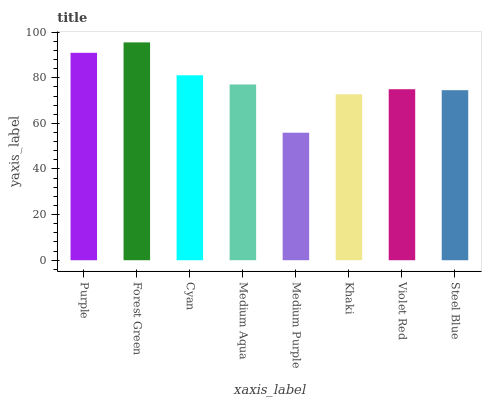Is Medium Purple the minimum?
Answer yes or no. Yes. Is Forest Green the maximum?
Answer yes or no. Yes. Is Cyan the minimum?
Answer yes or no. No. Is Cyan the maximum?
Answer yes or no. No. Is Forest Green greater than Cyan?
Answer yes or no. Yes. Is Cyan less than Forest Green?
Answer yes or no. Yes. Is Cyan greater than Forest Green?
Answer yes or no. No. Is Forest Green less than Cyan?
Answer yes or no. No. Is Medium Aqua the high median?
Answer yes or no. Yes. Is Violet Red the low median?
Answer yes or no. Yes. Is Khaki the high median?
Answer yes or no. No. Is Forest Green the low median?
Answer yes or no. No. 